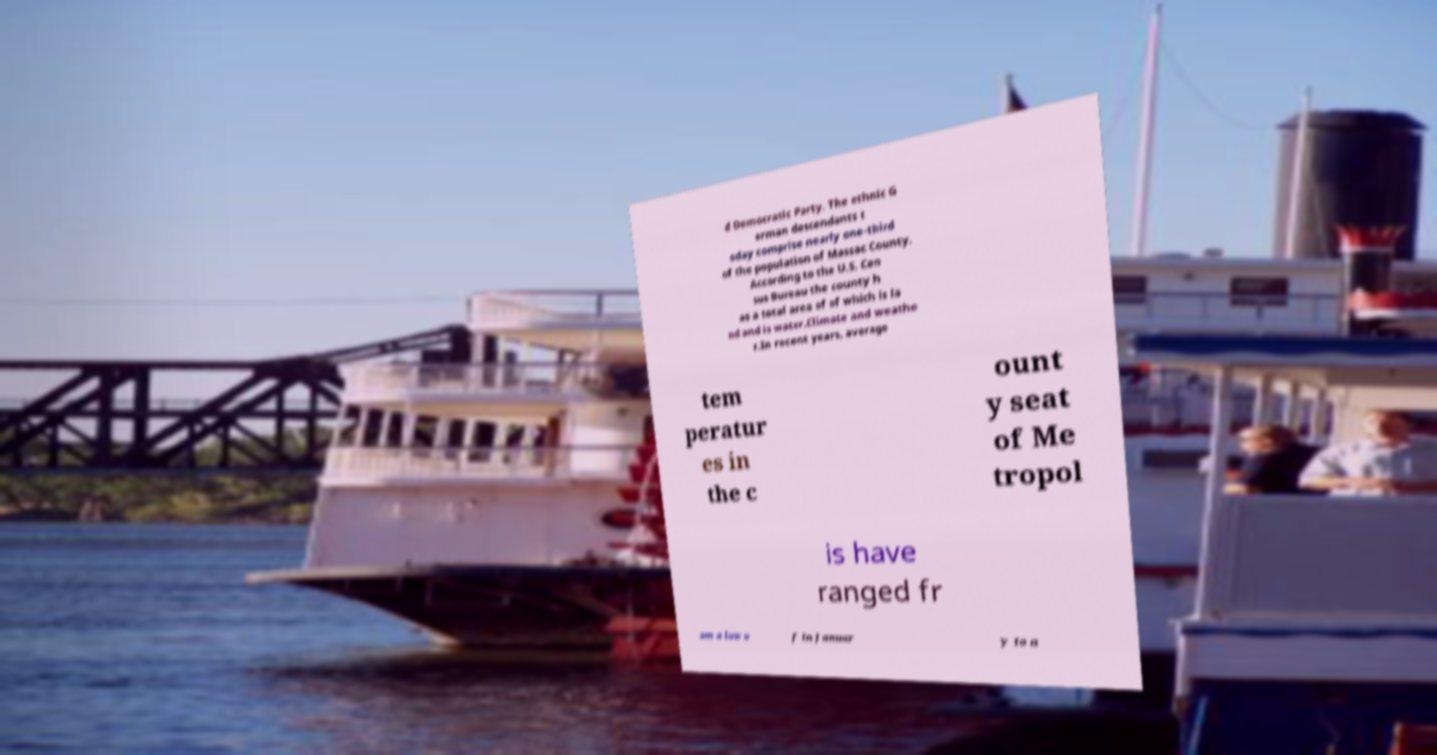Can you read and provide the text displayed in the image?This photo seems to have some interesting text. Can you extract and type it out for me? d Democratic Party. The ethnic G erman descendants t oday comprise nearly one-third of the population of Massac County. According to the U.S. Cen sus Bureau the county h as a total area of of which is la nd and is water.Climate and weathe r.In recent years, average tem peratur es in the c ount y seat of Me tropol is have ranged fr om a low o f in Januar y to a 